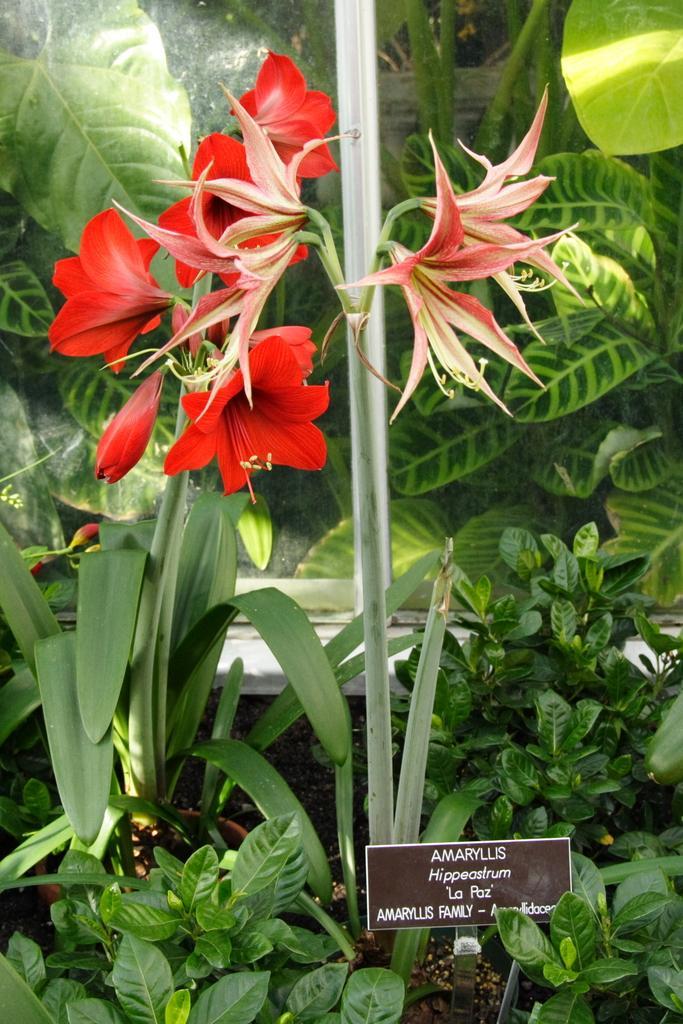Can you describe this image briefly? In this image I can see a plant. We can see a red color flower and green leaves. I can see brown color board and something is written on it. 